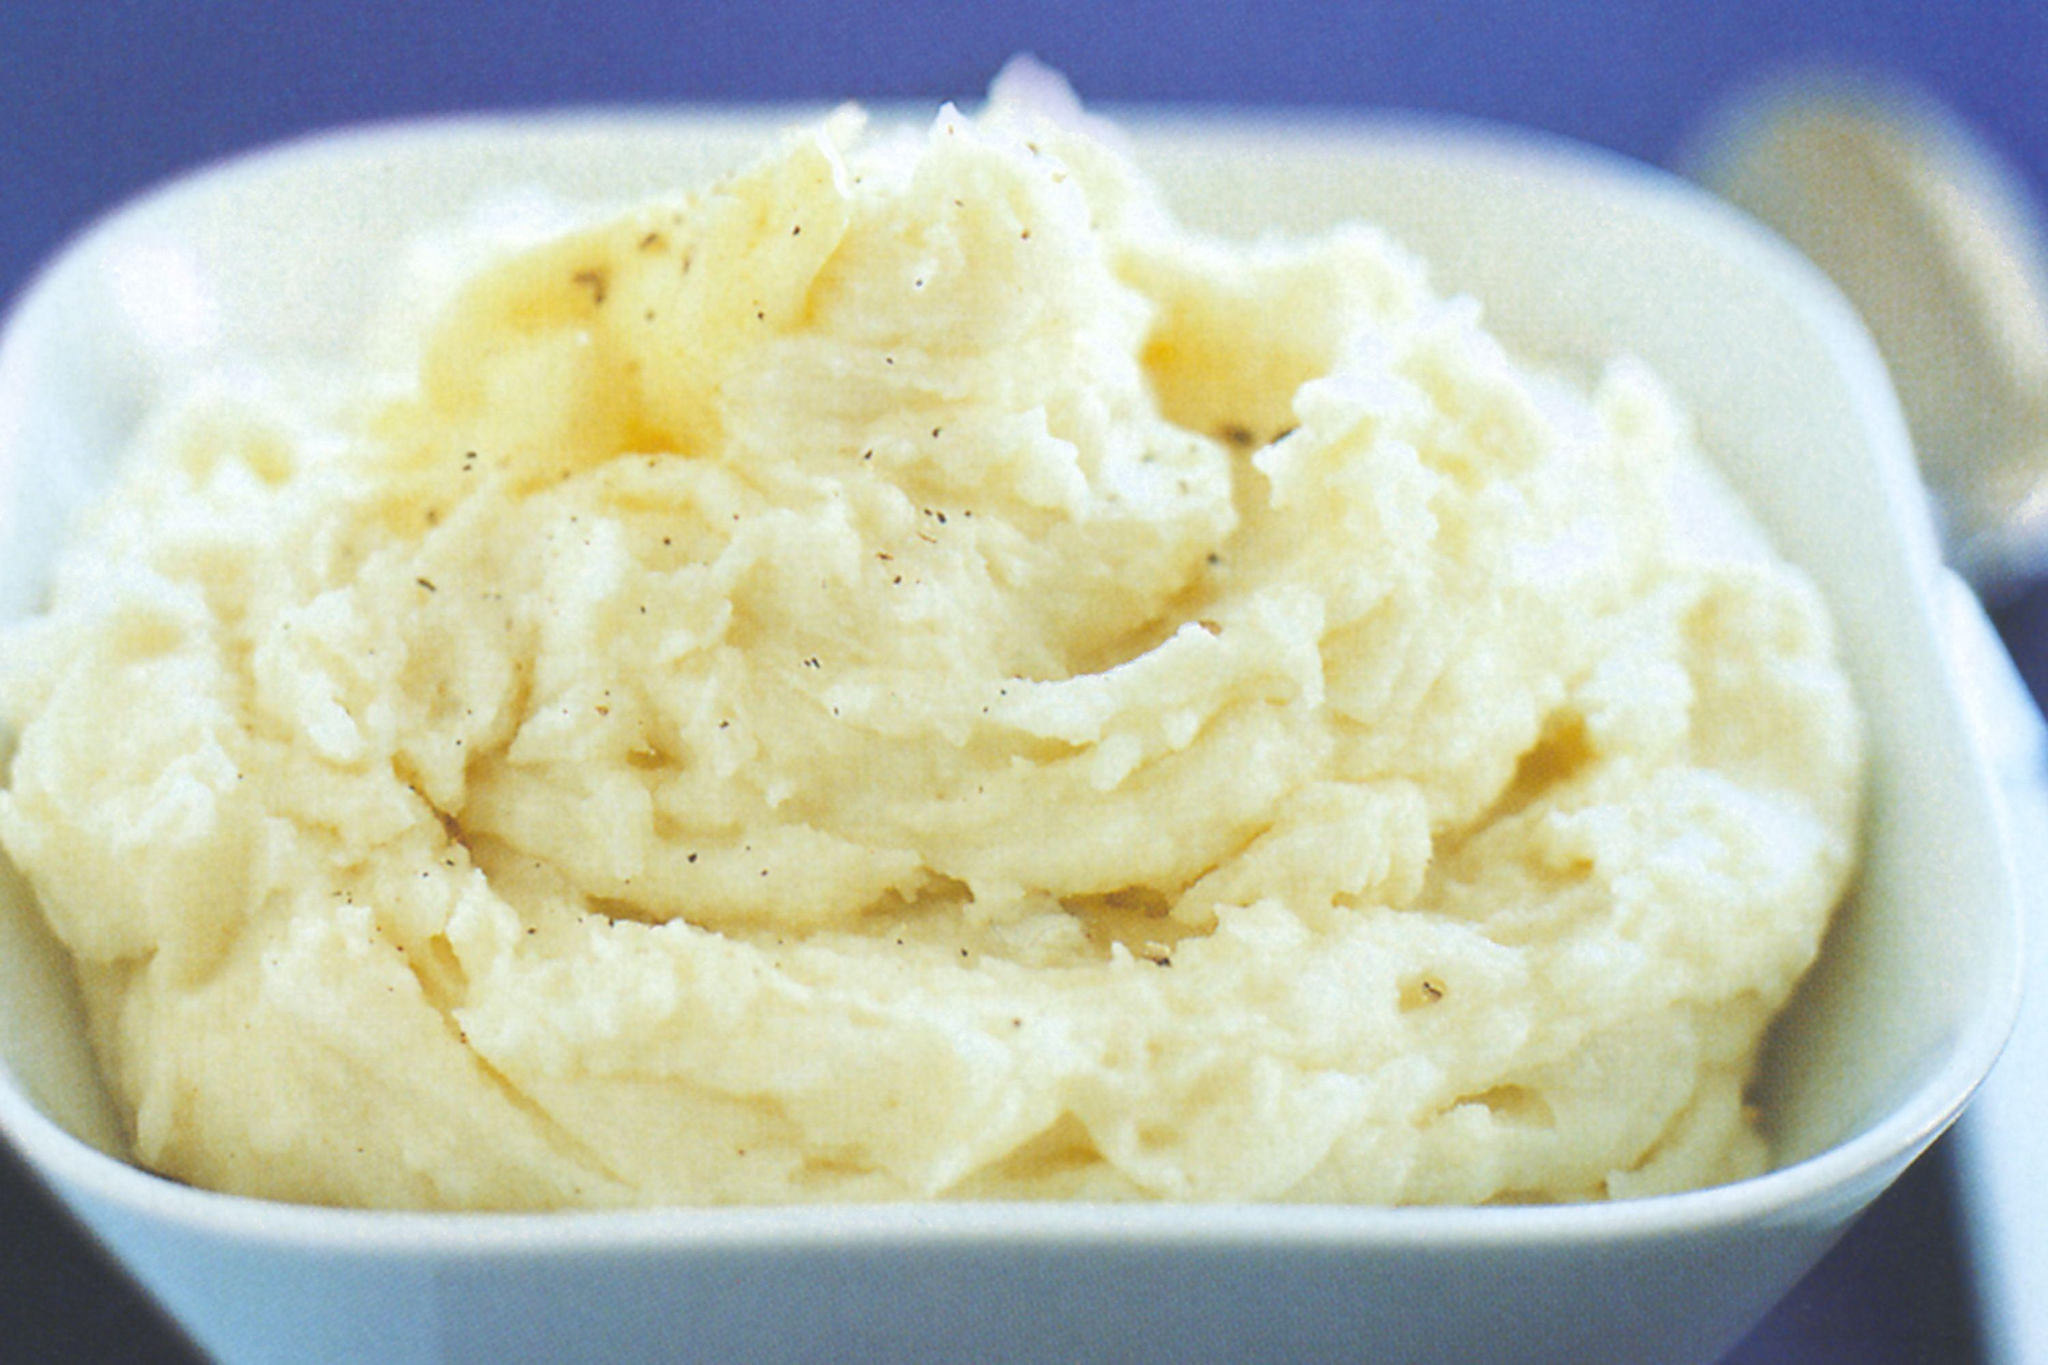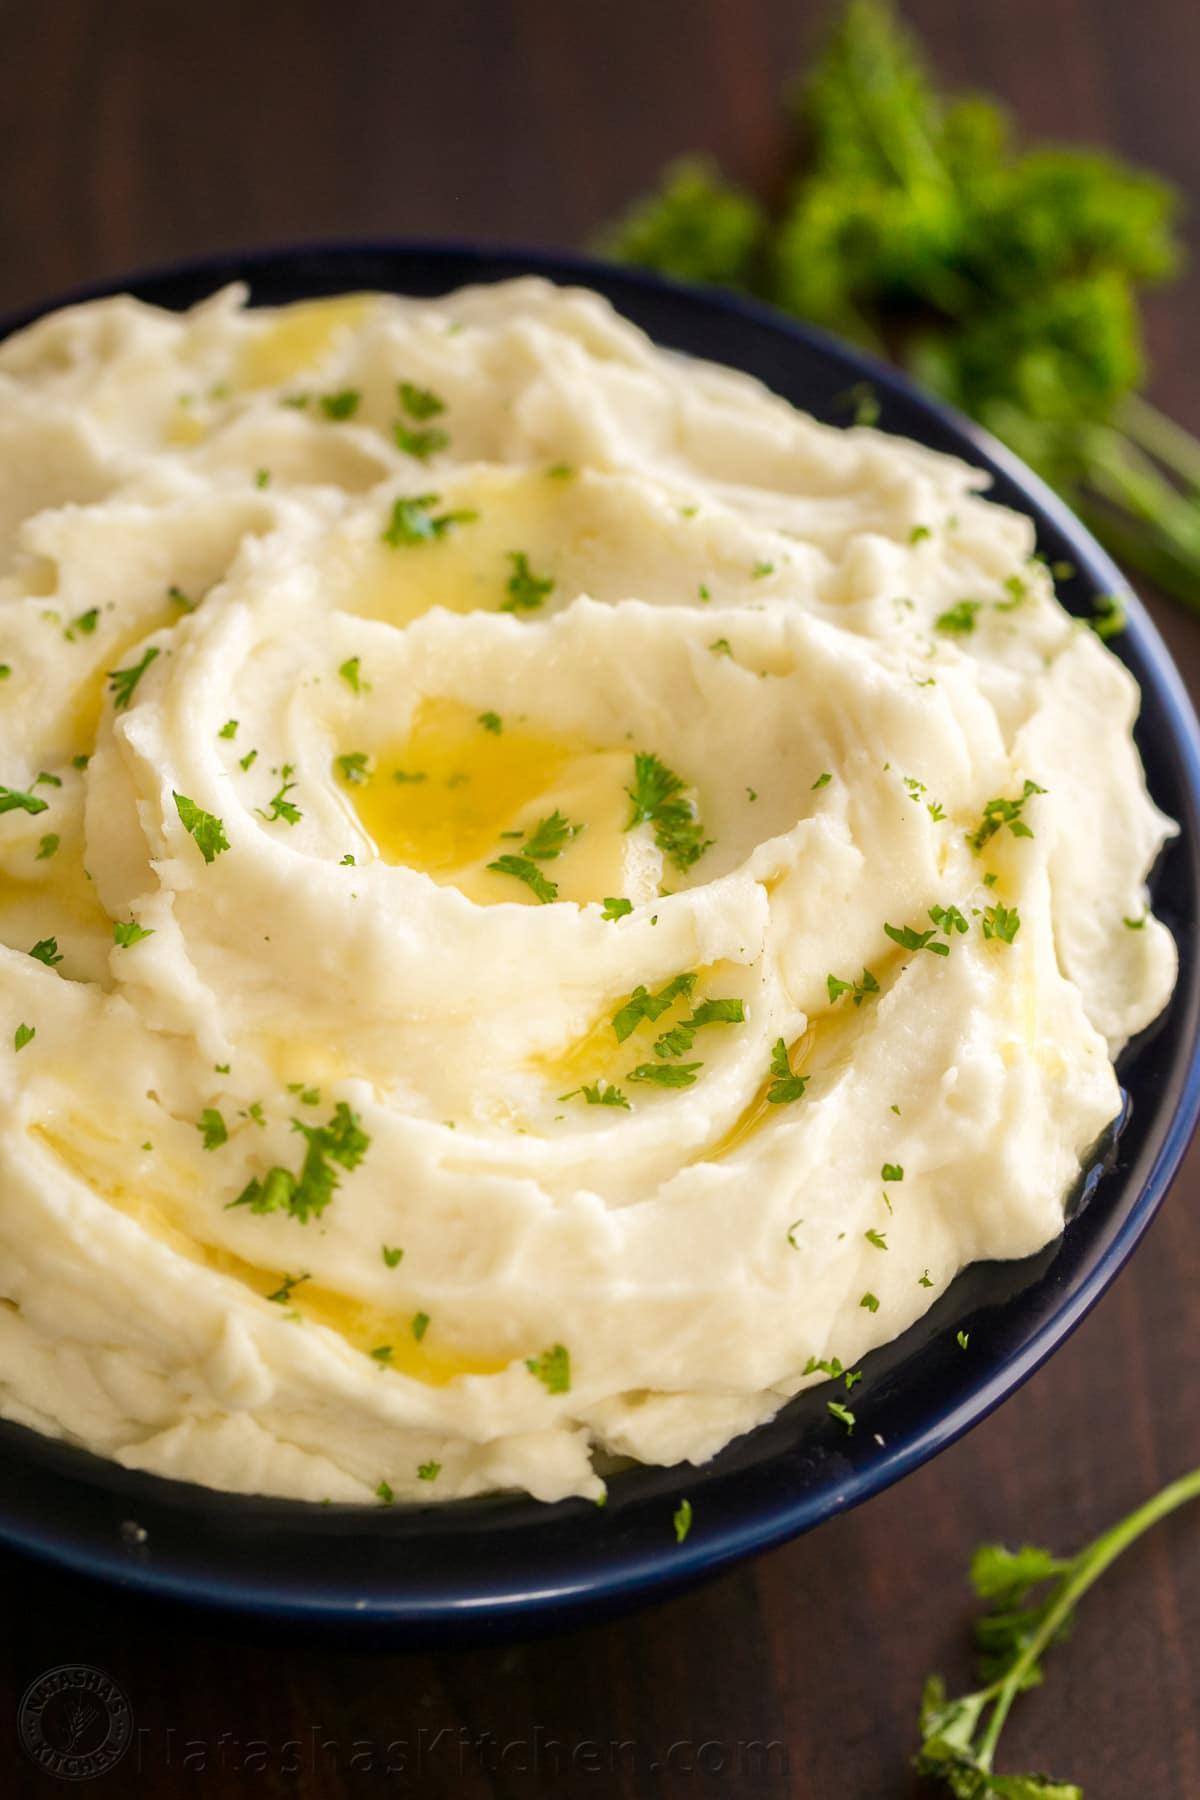The first image is the image on the left, the second image is the image on the right. Evaluate the accuracy of this statement regarding the images: "At least one image has a bowl of mashed potatoes, garnished with parsley, and parlest visible on the dark wooden surface beside the bowl.". Is it true? Answer yes or no. Yes. The first image is the image on the left, the second image is the image on the right. Analyze the images presented: Is the assertion "The mashed potatoes on the right have a spoon handle visibly sticking out of them" valid? Answer yes or no. No. 